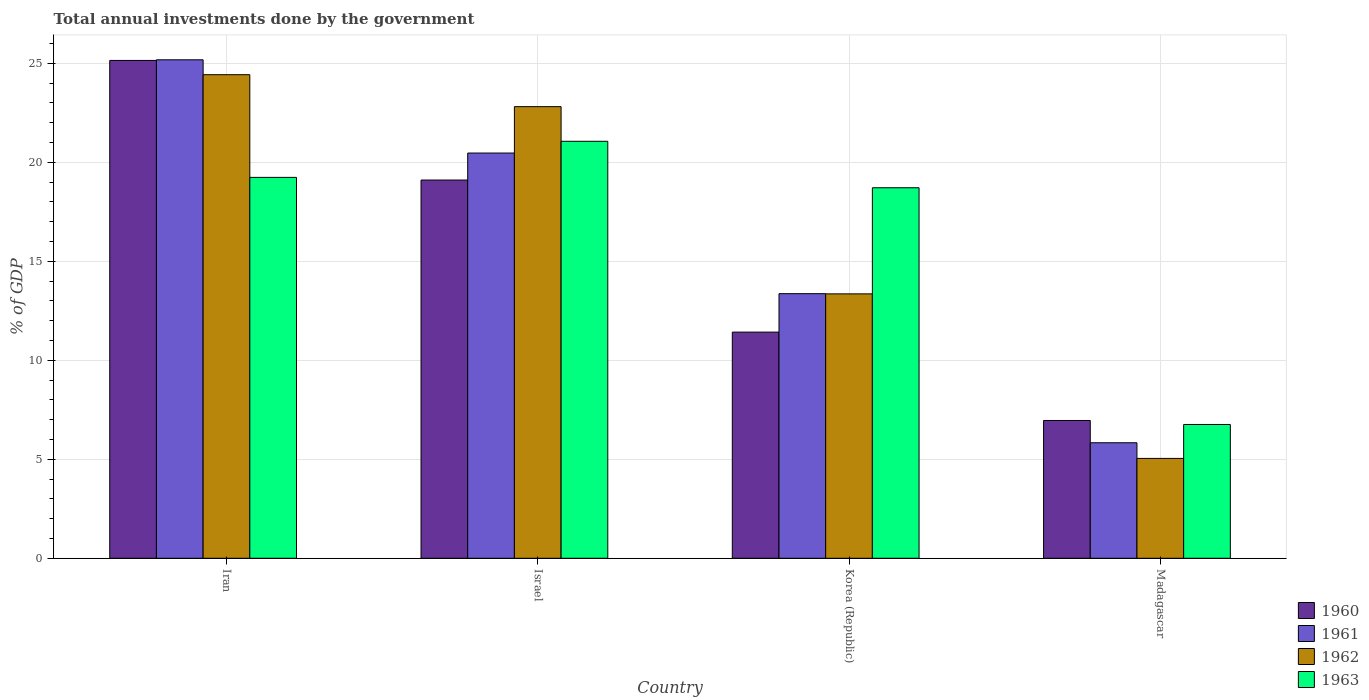How many groups of bars are there?
Give a very brief answer. 4. How many bars are there on the 2nd tick from the right?
Offer a terse response. 4. What is the label of the 1st group of bars from the left?
Offer a terse response. Iran. In how many cases, is the number of bars for a given country not equal to the number of legend labels?
Give a very brief answer. 0. What is the total annual investments done by the government in 1963 in Madagascar?
Your answer should be compact. 6.76. Across all countries, what is the maximum total annual investments done by the government in 1962?
Offer a very short reply. 24.43. Across all countries, what is the minimum total annual investments done by the government in 1963?
Your response must be concise. 6.76. In which country was the total annual investments done by the government in 1963 minimum?
Your answer should be compact. Madagascar. What is the total total annual investments done by the government in 1963 in the graph?
Your response must be concise. 65.78. What is the difference between the total annual investments done by the government in 1963 in Israel and that in Korea (Republic)?
Your answer should be very brief. 2.35. What is the difference between the total annual investments done by the government in 1963 in Madagascar and the total annual investments done by the government in 1961 in Israel?
Your response must be concise. -13.71. What is the average total annual investments done by the government in 1961 per country?
Your answer should be very brief. 16.21. What is the difference between the total annual investments done by the government of/in 1961 and total annual investments done by the government of/in 1963 in Israel?
Your answer should be very brief. -0.59. What is the ratio of the total annual investments done by the government in 1963 in Iran to that in Korea (Republic)?
Keep it short and to the point. 1.03. Is the total annual investments done by the government in 1963 in Iran less than that in Israel?
Your answer should be compact. Yes. What is the difference between the highest and the second highest total annual investments done by the government in 1960?
Provide a short and direct response. -13.72. What is the difference between the highest and the lowest total annual investments done by the government in 1962?
Keep it short and to the point. 19.38. Is the sum of the total annual investments done by the government in 1961 in Israel and Madagascar greater than the maximum total annual investments done by the government in 1962 across all countries?
Make the answer very short. Yes. Is it the case that in every country, the sum of the total annual investments done by the government in 1961 and total annual investments done by the government in 1963 is greater than the sum of total annual investments done by the government in 1960 and total annual investments done by the government in 1962?
Offer a very short reply. No. What does the 3rd bar from the left in Israel represents?
Your answer should be very brief. 1962. What does the 3rd bar from the right in Iran represents?
Give a very brief answer. 1961. How many countries are there in the graph?
Offer a very short reply. 4. Are the values on the major ticks of Y-axis written in scientific E-notation?
Ensure brevity in your answer.  No. Does the graph contain any zero values?
Provide a succinct answer. No. Does the graph contain grids?
Provide a short and direct response. Yes. How are the legend labels stacked?
Keep it short and to the point. Vertical. What is the title of the graph?
Keep it short and to the point. Total annual investments done by the government. What is the label or title of the Y-axis?
Provide a succinct answer. % of GDP. What is the % of GDP in 1960 in Iran?
Provide a succinct answer. 25.15. What is the % of GDP of 1961 in Iran?
Offer a terse response. 25.18. What is the % of GDP of 1962 in Iran?
Offer a very short reply. 24.43. What is the % of GDP in 1963 in Iran?
Keep it short and to the point. 19.24. What is the % of GDP in 1960 in Israel?
Keep it short and to the point. 19.11. What is the % of GDP of 1961 in Israel?
Ensure brevity in your answer.  20.47. What is the % of GDP of 1962 in Israel?
Keep it short and to the point. 22.82. What is the % of GDP of 1963 in Israel?
Offer a very short reply. 21.06. What is the % of GDP of 1960 in Korea (Republic)?
Your response must be concise. 11.43. What is the % of GDP in 1961 in Korea (Republic)?
Your response must be concise. 13.37. What is the % of GDP in 1962 in Korea (Republic)?
Offer a very short reply. 13.36. What is the % of GDP in 1963 in Korea (Republic)?
Keep it short and to the point. 18.72. What is the % of GDP in 1960 in Madagascar?
Your answer should be compact. 6.96. What is the % of GDP in 1961 in Madagascar?
Provide a short and direct response. 5.84. What is the % of GDP of 1962 in Madagascar?
Provide a short and direct response. 5.04. What is the % of GDP of 1963 in Madagascar?
Keep it short and to the point. 6.76. Across all countries, what is the maximum % of GDP in 1960?
Make the answer very short. 25.15. Across all countries, what is the maximum % of GDP of 1961?
Keep it short and to the point. 25.18. Across all countries, what is the maximum % of GDP in 1962?
Give a very brief answer. 24.43. Across all countries, what is the maximum % of GDP of 1963?
Your response must be concise. 21.06. Across all countries, what is the minimum % of GDP in 1960?
Provide a short and direct response. 6.96. Across all countries, what is the minimum % of GDP in 1961?
Keep it short and to the point. 5.84. Across all countries, what is the minimum % of GDP of 1962?
Provide a short and direct response. 5.04. Across all countries, what is the minimum % of GDP of 1963?
Provide a short and direct response. 6.76. What is the total % of GDP of 1960 in the graph?
Offer a terse response. 62.64. What is the total % of GDP in 1961 in the graph?
Provide a short and direct response. 64.86. What is the total % of GDP of 1962 in the graph?
Offer a very short reply. 65.65. What is the total % of GDP of 1963 in the graph?
Provide a succinct answer. 65.78. What is the difference between the % of GDP of 1960 in Iran and that in Israel?
Your answer should be compact. 6.04. What is the difference between the % of GDP of 1961 in Iran and that in Israel?
Ensure brevity in your answer.  4.71. What is the difference between the % of GDP of 1962 in Iran and that in Israel?
Keep it short and to the point. 1.61. What is the difference between the % of GDP in 1963 in Iran and that in Israel?
Your answer should be very brief. -1.82. What is the difference between the % of GDP in 1960 in Iran and that in Korea (Republic)?
Keep it short and to the point. 13.72. What is the difference between the % of GDP of 1961 in Iran and that in Korea (Republic)?
Keep it short and to the point. 11.81. What is the difference between the % of GDP in 1962 in Iran and that in Korea (Republic)?
Ensure brevity in your answer.  11.07. What is the difference between the % of GDP in 1963 in Iran and that in Korea (Republic)?
Offer a terse response. 0.52. What is the difference between the % of GDP of 1960 in Iran and that in Madagascar?
Provide a succinct answer. 18.19. What is the difference between the % of GDP in 1961 in Iran and that in Madagascar?
Give a very brief answer. 19.35. What is the difference between the % of GDP of 1962 in Iran and that in Madagascar?
Offer a terse response. 19.38. What is the difference between the % of GDP in 1963 in Iran and that in Madagascar?
Offer a very short reply. 12.48. What is the difference between the % of GDP in 1960 in Israel and that in Korea (Republic)?
Your answer should be compact. 7.68. What is the difference between the % of GDP of 1961 in Israel and that in Korea (Republic)?
Your answer should be very brief. 7.1. What is the difference between the % of GDP of 1962 in Israel and that in Korea (Republic)?
Give a very brief answer. 9.46. What is the difference between the % of GDP of 1963 in Israel and that in Korea (Republic)?
Your response must be concise. 2.35. What is the difference between the % of GDP in 1960 in Israel and that in Madagascar?
Provide a short and direct response. 12.15. What is the difference between the % of GDP in 1961 in Israel and that in Madagascar?
Your answer should be compact. 14.64. What is the difference between the % of GDP in 1962 in Israel and that in Madagascar?
Offer a terse response. 17.77. What is the difference between the % of GDP in 1963 in Israel and that in Madagascar?
Make the answer very short. 14.31. What is the difference between the % of GDP in 1960 in Korea (Republic) and that in Madagascar?
Provide a short and direct response. 4.46. What is the difference between the % of GDP of 1961 in Korea (Republic) and that in Madagascar?
Your answer should be very brief. 7.53. What is the difference between the % of GDP of 1962 in Korea (Republic) and that in Madagascar?
Your answer should be very brief. 8.31. What is the difference between the % of GDP in 1963 in Korea (Republic) and that in Madagascar?
Provide a short and direct response. 11.96. What is the difference between the % of GDP of 1960 in Iran and the % of GDP of 1961 in Israel?
Offer a terse response. 4.68. What is the difference between the % of GDP in 1960 in Iran and the % of GDP in 1962 in Israel?
Make the answer very short. 2.33. What is the difference between the % of GDP in 1960 in Iran and the % of GDP in 1963 in Israel?
Keep it short and to the point. 4.08. What is the difference between the % of GDP of 1961 in Iran and the % of GDP of 1962 in Israel?
Make the answer very short. 2.37. What is the difference between the % of GDP of 1961 in Iran and the % of GDP of 1963 in Israel?
Your answer should be very brief. 4.12. What is the difference between the % of GDP of 1962 in Iran and the % of GDP of 1963 in Israel?
Offer a very short reply. 3.36. What is the difference between the % of GDP of 1960 in Iran and the % of GDP of 1961 in Korea (Republic)?
Keep it short and to the point. 11.78. What is the difference between the % of GDP of 1960 in Iran and the % of GDP of 1962 in Korea (Republic)?
Make the answer very short. 11.79. What is the difference between the % of GDP in 1960 in Iran and the % of GDP in 1963 in Korea (Republic)?
Provide a succinct answer. 6.43. What is the difference between the % of GDP in 1961 in Iran and the % of GDP in 1962 in Korea (Republic)?
Provide a succinct answer. 11.82. What is the difference between the % of GDP in 1961 in Iran and the % of GDP in 1963 in Korea (Republic)?
Your response must be concise. 6.46. What is the difference between the % of GDP in 1962 in Iran and the % of GDP in 1963 in Korea (Republic)?
Your answer should be very brief. 5.71. What is the difference between the % of GDP of 1960 in Iran and the % of GDP of 1961 in Madagascar?
Your answer should be very brief. 19.31. What is the difference between the % of GDP in 1960 in Iran and the % of GDP in 1962 in Madagascar?
Make the answer very short. 20.11. What is the difference between the % of GDP of 1960 in Iran and the % of GDP of 1963 in Madagascar?
Keep it short and to the point. 18.39. What is the difference between the % of GDP of 1961 in Iran and the % of GDP of 1962 in Madagascar?
Your answer should be very brief. 20.14. What is the difference between the % of GDP of 1961 in Iran and the % of GDP of 1963 in Madagascar?
Make the answer very short. 18.42. What is the difference between the % of GDP of 1962 in Iran and the % of GDP of 1963 in Madagascar?
Provide a short and direct response. 17.67. What is the difference between the % of GDP of 1960 in Israel and the % of GDP of 1961 in Korea (Republic)?
Offer a very short reply. 5.74. What is the difference between the % of GDP of 1960 in Israel and the % of GDP of 1962 in Korea (Republic)?
Provide a succinct answer. 5.75. What is the difference between the % of GDP of 1960 in Israel and the % of GDP of 1963 in Korea (Republic)?
Your response must be concise. 0.39. What is the difference between the % of GDP of 1961 in Israel and the % of GDP of 1962 in Korea (Republic)?
Your answer should be very brief. 7.11. What is the difference between the % of GDP in 1961 in Israel and the % of GDP in 1963 in Korea (Republic)?
Give a very brief answer. 1.75. What is the difference between the % of GDP in 1962 in Israel and the % of GDP in 1963 in Korea (Republic)?
Offer a terse response. 4.1. What is the difference between the % of GDP of 1960 in Israel and the % of GDP of 1961 in Madagascar?
Give a very brief answer. 13.27. What is the difference between the % of GDP in 1960 in Israel and the % of GDP in 1962 in Madagascar?
Make the answer very short. 14.06. What is the difference between the % of GDP of 1960 in Israel and the % of GDP of 1963 in Madagascar?
Provide a succinct answer. 12.35. What is the difference between the % of GDP of 1961 in Israel and the % of GDP of 1962 in Madagascar?
Your response must be concise. 15.43. What is the difference between the % of GDP in 1961 in Israel and the % of GDP in 1963 in Madagascar?
Give a very brief answer. 13.71. What is the difference between the % of GDP in 1962 in Israel and the % of GDP in 1963 in Madagascar?
Make the answer very short. 16.06. What is the difference between the % of GDP in 1960 in Korea (Republic) and the % of GDP in 1961 in Madagascar?
Offer a terse response. 5.59. What is the difference between the % of GDP in 1960 in Korea (Republic) and the % of GDP in 1962 in Madagascar?
Your response must be concise. 6.38. What is the difference between the % of GDP in 1960 in Korea (Republic) and the % of GDP in 1963 in Madagascar?
Keep it short and to the point. 4.67. What is the difference between the % of GDP in 1961 in Korea (Republic) and the % of GDP in 1962 in Madagascar?
Offer a terse response. 8.32. What is the difference between the % of GDP in 1961 in Korea (Republic) and the % of GDP in 1963 in Madagascar?
Ensure brevity in your answer.  6.61. What is the difference between the % of GDP of 1962 in Korea (Republic) and the % of GDP of 1963 in Madagascar?
Your response must be concise. 6.6. What is the average % of GDP of 1960 per country?
Offer a terse response. 15.66. What is the average % of GDP of 1961 per country?
Make the answer very short. 16.21. What is the average % of GDP in 1962 per country?
Give a very brief answer. 16.41. What is the average % of GDP of 1963 per country?
Give a very brief answer. 16.45. What is the difference between the % of GDP of 1960 and % of GDP of 1961 in Iran?
Make the answer very short. -0.03. What is the difference between the % of GDP in 1960 and % of GDP in 1962 in Iran?
Give a very brief answer. 0.72. What is the difference between the % of GDP of 1960 and % of GDP of 1963 in Iran?
Your answer should be very brief. 5.91. What is the difference between the % of GDP of 1961 and % of GDP of 1962 in Iran?
Make the answer very short. 0.75. What is the difference between the % of GDP of 1961 and % of GDP of 1963 in Iran?
Make the answer very short. 5.94. What is the difference between the % of GDP in 1962 and % of GDP in 1963 in Iran?
Make the answer very short. 5.19. What is the difference between the % of GDP in 1960 and % of GDP in 1961 in Israel?
Keep it short and to the point. -1.36. What is the difference between the % of GDP in 1960 and % of GDP in 1962 in Israel?
Your answer should be compact. -3.71. What is the difference between the % of GDP of 1960 and % of GDP of 1963 in Israel?
Your response must be concise. -1.96. What is the difference between the % of GDP in 1961 and % of GDP in 1962 in Israel?
Your answer should be very brief. -2.34. What is the difference between the % of GDP of 1961 and % of GDP of 1963 in Israel?
Provide a short and direct response. -0.59. What is the difference between the % of GDP of 1962 and % of GDP of 1963 in Israel?
Provide a succinct answer. 1.75. What is the difference between the % of GDP of 1960 and % of GDP of 1961 in Korea (Republic)?
Your answer should be very brief. -1.94. What is the difference between the % of GDP of 1960 and % of GDP of 1962 in Korea (Republic)?
Your answer should be compact. -1.93. What is the difference between the % of GDP in 1960 and % of GDP in 1963 in Korea (Republic)?
Your answer should be compact. -7.29. What is the difference between the % of GDP in 1961 and % of GDP in 1962 in Korea (Republic)?
Offer a terse response. 0.01. What is the difference between the % of GDP of 1961 and % of GDP of 1963 in Korea (Republic)?
Provide a short and direct response. -5.35. What is the difference between the % of GDP of 1962 and % of GDP of 1963 in Korea (Republic)?
Offer a very short reply. -5.36. What is the difference between the % of GDP of 1960 and % of GDP of 1961 in Madagascar?
Offer a very short reply. 1.13. What is the difference between the % of GDP in 1960 and % of GDP in 1962 in Madagascar?
Offer a terse response. 1.92. What is the difference between the % of GDP of 1960 and % of GDP of 1963 in Madagascar?
Give a very brief answer. 0.2. What is the difference between the % of GDP in 1961 and % of GDP in 1962 in Madagascar?
Your response must be concise. 0.79. What is the difference between the % of GDP in 1961 and % of GDP in 1963 in Madagascar?
Keep it short and to the point. -0.92. What is the difference between the % of GDP of 1962 and % of GDP of 1963 in Madagascar?
Your response must be concise. -1.71. What is the ratio of the % of GDP of 1960 in Iran to that in Israel?
Keep it short and to the point. 1.32. What is the ratio of the % of GDP in 1961 in Iran to that in Israel?
Give a very brief answer. 1.23. What is the ratio of the % of GDP of 1962 in Iran to that in Israel?
Offer a terse response. 1.07. What is the ratio of the % of GDP of 1963 in Iran to that in Israel?
Provide a succinct answer. 0.91. What is the ratio of the % of GDP of 1960 in Iran to that in Korea (Republic)?
Your answer should be very brief. 2.2. What is the ratio of the % of GDP of 1961 in Iran to that in Korea (Republic)?
Ensure brevity in your answer.  1.88. What is the ratio of the % of GDP of 1962 in Iran to that in Korea (Republic)?
Your response must be concise. 1.83. What is the ratio of the % of GDP in 1963 in Iran to that in Korea (Republic)?
Ensure brevity in your answer.  1.03. What is the ratio of the % of GDP of 1960 in Iran to that in Madagascar?
Ensure brevity in your answer.  3.61. What is the ratio of the % of GDP in 1961 in Iran to that in Madagascar?
Provide a short and direct response. 4.32. What is the ratio of the % of GDP of 1962 in Iran to that in Madagascar?
Make the answer very short. 4.84. What is the ratio of the % of GDP of 1963 in Iran to that in Madagascar?
Your response must be concise. 2.85. What is the ratio of the % of GDP of 1960 in Israel to that in Korea (Republic)?
Offer a very short reply. 1.67. What is the ratio of the % of GDP of 1961 in Israel to that in Korea (Republic)?
Offer a very short reply. 1.53. What is the ratio of the % of GDP of 1962 in Israel to that in Korea (Republic)?
Offer a very short reply. 1.71. What is the ratio of the % of GDP of 1963 in Israel to that in Korea (Republic)?
Give a very brief answer. 1.13. What is the ratio of the % of GDP of 1960 in Israel to that in Madagascar?
Offer a terse response. 2.74. What is the ratio of the % of GDP in 1961 in Israel to that in Madagascar?
Ensure brevity in your answer.  3.51. What is the ratio of the % of GDP in 1962 in Israel to that in Madagascar?
Your response must be concise. 4.52. What is the ratio of the % of GDP of 1963 in Israel to that in Madagascar?
Give a very brief answer. 3.12. What is the ratio of the % of GDP in 1960 in Korea (Republic) to that in Madagascar?
Provide a succinct answer. 1.64. What is the ratio of the % of GDP in 1961 in Korea (Republic) to that in Madagascar?
Provide a short and direct response. 2.29. What is the ratio of the % of GDP of 1962 in Korea (Republic) to that in Madagascar?
Offer a terse response. 2.65. What is the ratio of the % of GDP of 1963 in Korea (Republic) to that in Madagascar?
Your answer should be very brief. 2.77. What is the difference between the highest and the second highest % of GDP in 1960?
Provide a short and direct response. 6.04. What is the difference between the highest and the second highest % of GDP in 1961?
Provide a succinct answer. 4.71. What is the difference between the highest and the second highest % of GDP of 1962?
Offer a very short reply. 1.61. What is the difference between the highest and the second highest % of GDP of 1963?
Ensure brevity in your answer.  1.82. What is the difference between the highest and the lowest % of GDP of 1960?
Your response must be concise. 18.19. What is the difference between the highest and the lowest % of GDP in 1961?
Provide a short and direct response. 19.35. What is the difference between the highest and the lowest % of GDP of 1962?
Provide a short and direct response. 19.38. What is the difference between the highest and the lowest % of GDP of 1963?
Your answer should be very brief. 14.31. 